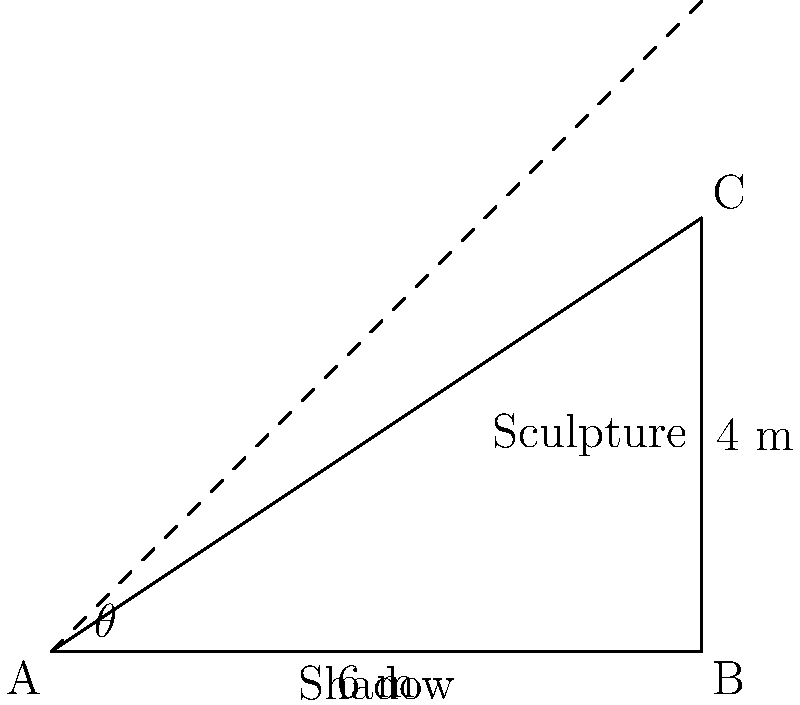As part of a public art installation, you've created a 4-meter tall sculpture. At a certain time of day, the sculpture casts a 6-meter long shadow. What is the angle of elevation of the sun at this moment? Express your answer to the nearest degree. To solve this problem, we'll use trigonometric ratios. Let's approach this step-by-step:

1) First, let's identify what we know:
   - The height of the sculpture is 4 meters
   - The length of the shadow is 6 meters

2) We need to find the angle of elevation of the sun. This angle is the same as the angle formed between the ground and the line from the top of the sculpture to the end of the shadow.

3) We can use the tangent ratio to find this angle. In a right triangle:

   $\tan(\theta) = \frac{\text{opposite}}{\text{adjacent}}$

4) In our case:
   - The opposite side is the height of the sculpture (4 meters)
   - The adjacent side is the length of the shadow (6 meters)

5) Let's plug these into our equation:

   $\tan(\theta) = \frac{4}{6} = \frac{2}{3}$

6) To find $\theta$, we need to use the inverse tangent (arctan or $\tan^{-1}$):

   $\theta = \tan^{-1}(\frac{2}{3})$

7) Using a calculator or computer:

   $\theta \approx 33.69^\circ$

8) Rounding to the nearest degree:

   $\theta \approx 34^\circ$

Therefore, the angle of elevation of the sun is approximately 34 degrees.
Answer: $34^\circ$ 